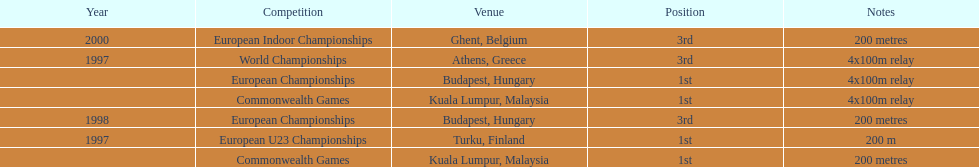List the competitions that have the same relay as world championships from athens, greece. European Championships, Commonwealth Games. 